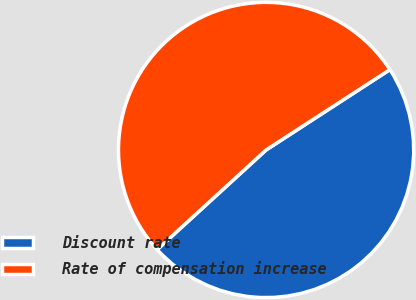Convert chart. <chart><loc_0><loc_0><loc_500><loc_500><pie_chart><fcel>Discount rate<fcel>Rate of compensation increase<nl><fcel>47.37%<fcel>52.63%<nl></chart> 